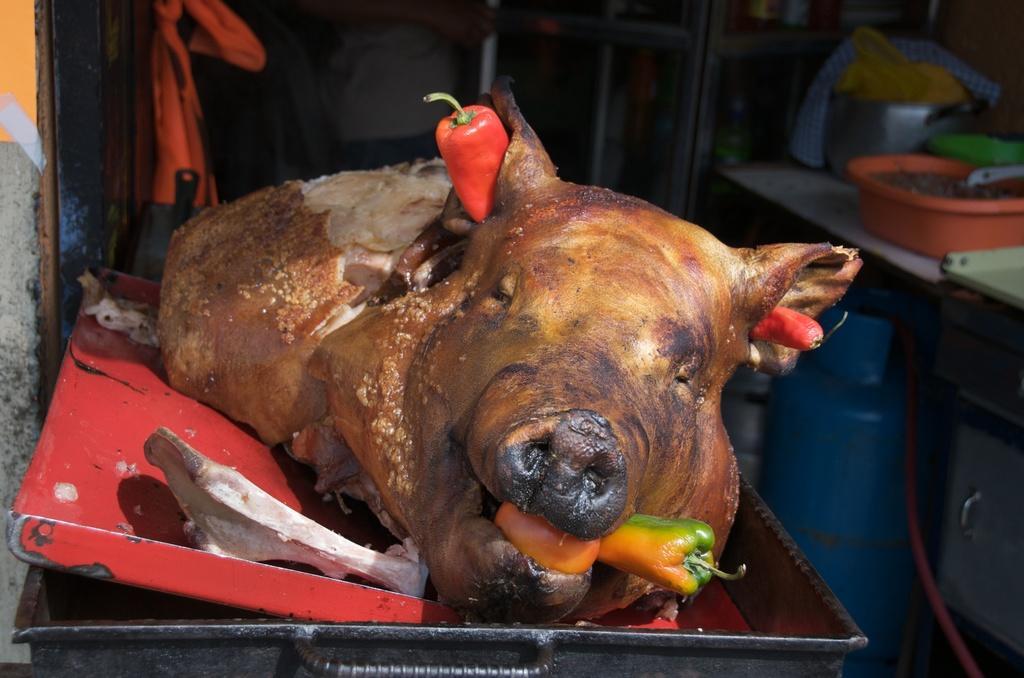How would you summarize this image in a sentence or two? In this picture we observe cooked pig kept on top of a tray and there are red and yellow bell peppers on it. 